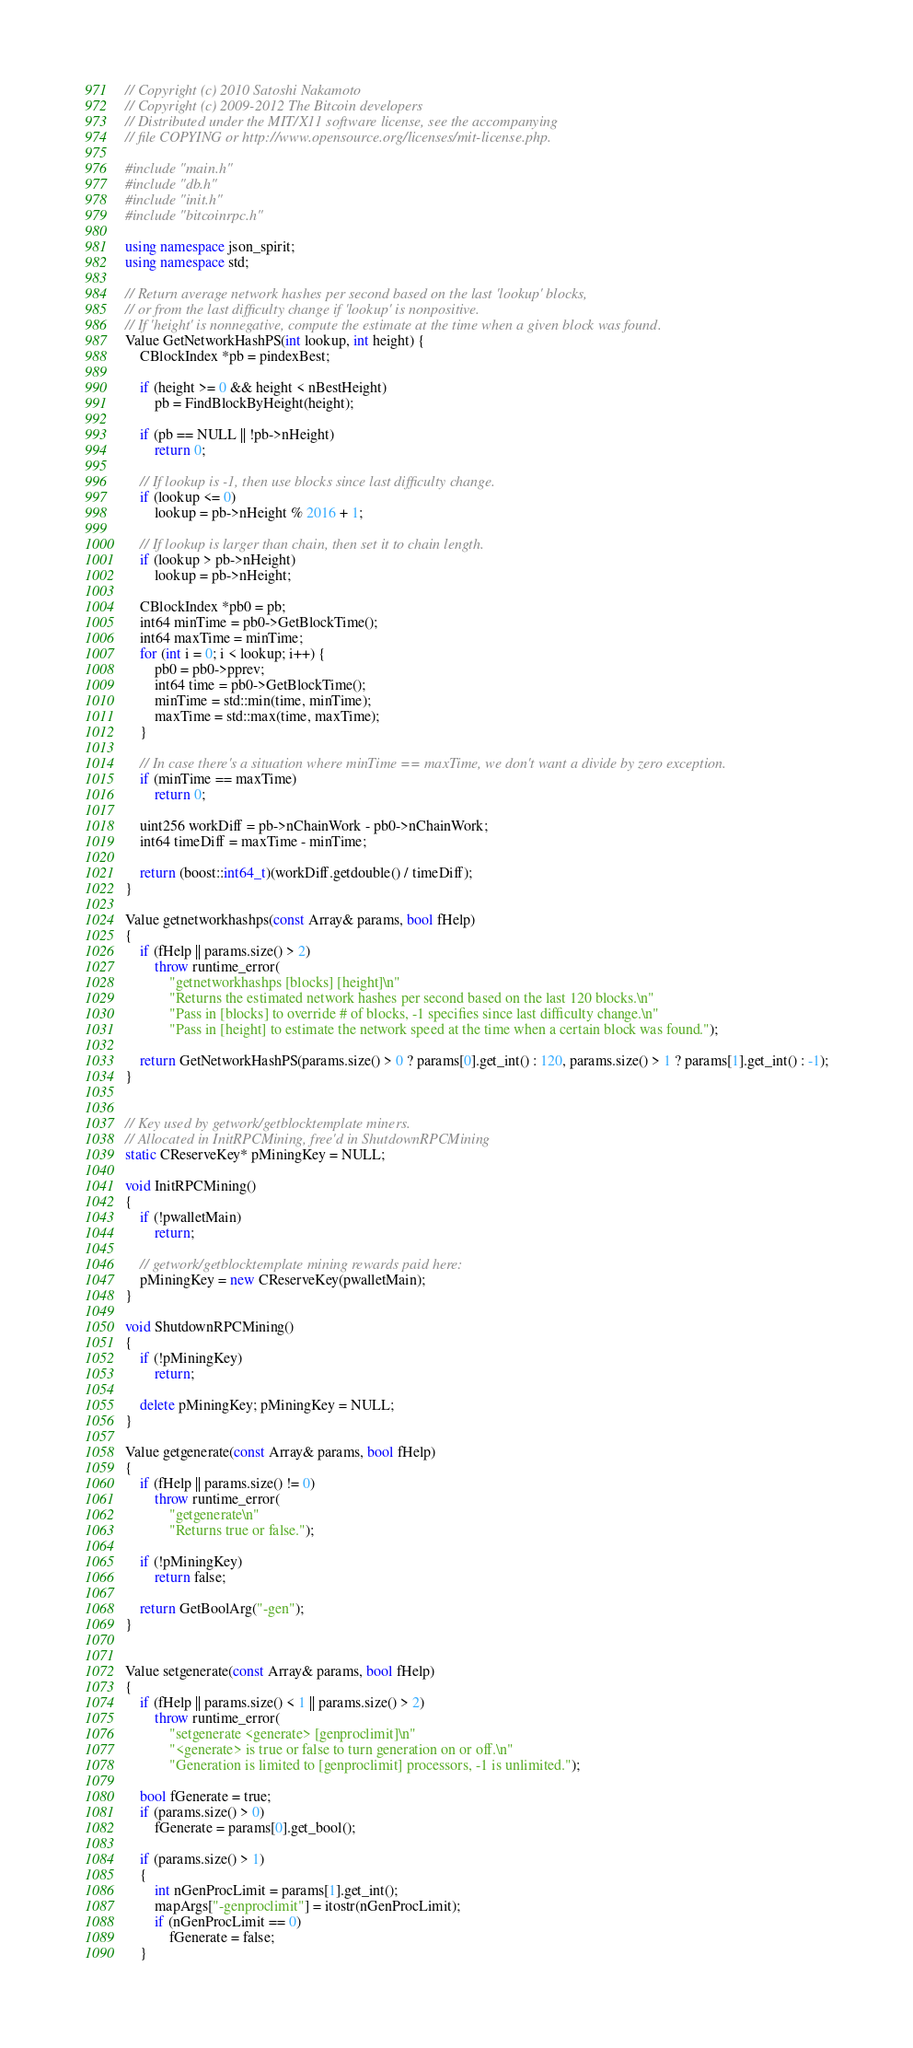<code> <loc_0><loc_0><loc_500><loc_500><_C++_>// Copyright (c) 2010 Satoshi Nakamoto
// Copyright (c) 2009-2012 The Bitcoin developers
// Distributed under the MIT/X11 software license, see the accompanying
// file COPYING or http://www.opensource.org/licenses/mit-license.php.

#include "main.h"
#include "db.h"
#include "init.h"
#include "bitcoinrpc.h"

using namespace json_spirit;
using namespace std;

// Return average network hashes per second based on the last 'lookup' blocks,
// or from the last difficulty change if 'lookup' is nonpositive.
// If 'height' is nonnegative, compute the estimate at the time when a given block was found.
Value GetNetworkHashPS(int lookup, int height) {
    CBlockIndex *pb = pindexBest;

    if (height >= 0 && height < nBestHeight)
        pb = FindBlockByHeight(height);

    if (pb == NULL || !pb->nHeight)
        return 0;

    // If lookup is -1, then use blocks since last difficulty change.
    if (lookup <= 0)
        lookup = pb->nHeight % 2016 + 1;

    // If lookup is larger than chain, then set it to chain length.
    if (lookup > pb->nHeight)
        lookup = pb->nHeight;

    CBlockIndex *pb0 = pb;
    int64 minTime = pb0->GetBlockTime();
    int64 maxTime = minTime;
    for (int i = 0; i < lookup; i++) {
        pb0 = pb0->pprev;
        int64 time = pb0->GetBlockTime();
        minTime = std::min(time, minTime);
        maxTime = std::max(time, maxTime);
    }

    // In case there's a situation where minTime == maxTime, we don't want a divide by zero exception.
    if (minTime == maxTime)
        return 0;

    uint256 workDiff = pb->nChainWork - pb0->nChainWork;
    int64 timeDiff = maxTime - minTime;

    return (boost::int64_t)(workDiff.getdouble() / timeDiff);
}

Value getnetworkhashps(const Array& params, bool fHelp)
{
    if (fHelp || params.size() > 2)
        throw runtime_error(
            "getnetworkhashps [blocks] [height]\n"
            "Returns the estimated network hashes per second based on the last 120 blocks.\n"
            "Pass in [blocks] to override # of blocks, -1 specifies since last difficulty change.\n"
            "Pass in [height] to estimate the network speed at the time when a certain block was found.");

    return GetNetworkHashPS(params.size() > 0 ? params[0].get_int() : 120, params.size() > 1 ? params[1].get_int() : -1);
}


// Key used by getwork/getblocktemplate miners.
// Allocated in InitRPCMining, free'd in ShutdownRPCMining
static CReserveKey* pMiningKey = NULL;

void InitRPCMining()
{
    if (!pwalletMain)
        return;

    // getwork/getblocktemplate mining rewards paid here:
    pMiningKey = new CReserveKey(pwalletMain);
}

void ShutdownRPCMining()
{
    if (!pMiningKey)
        return;

    delete pMiningKey; pMiningKey = NULL;
}

Value getgenerate(const Array& params, bool fHelp)
{
    if (fHelp || params.size() != 0)
        throw runtime_error(
            "getgenerate\n"
            "Returns true or false.");

    if (!pMiningKey)
        return false;

    return GetBoolArg("-gen");
}


Value setgenerate(const Array& params, bool fHelp)
{
    if (fHelp || params.size() < 1 || params.size() > 2)
        throw runtime_error(
            "setgenerate <generate> [genproclimit]\n"
            "<generate> is true or false to turn generation on or off.\n"
            "Generation is limited to [genproclimit] processors, -1 is unlimited.");

    bool fGenerate = true;
    if (params.size() > 0)
        fGenerate = params[0].get_bool();

    if (params.size() > 1)
    {
        int nGenProcLimit = params[1].get_int();
        mapArgs["-genproclimit"] = itostr(nGenProcLimit);
        if (nGenProcLimit == 0)
            fGenerate = false;
    }</code> 